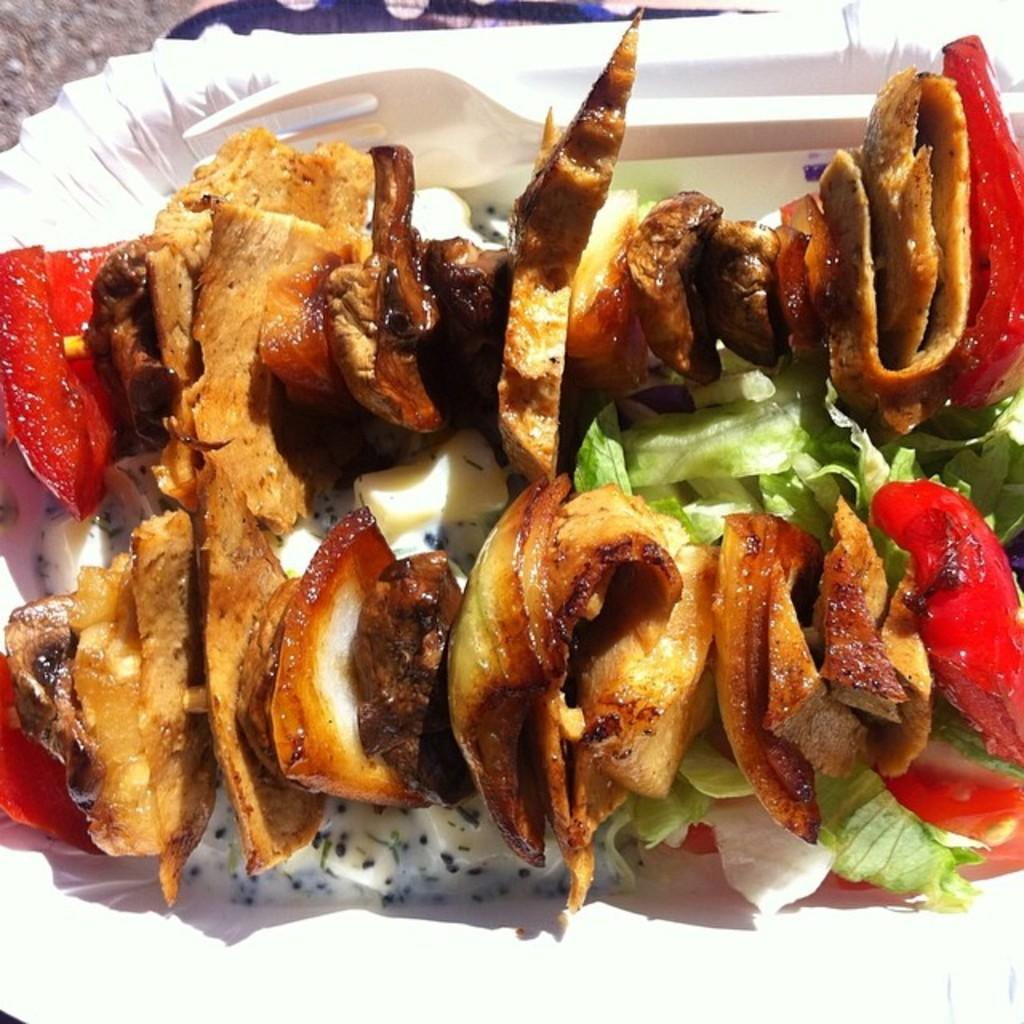What color is the plate in the image? The plate in the image is white. What is on the plate? There are food items on the plate. What utensil is visible in the image? There is a fork visible in the image. Can you see a potato on the plate in the image? There is no potato visible on the plate in the image. Is there a hook attached to the fork in the image? There is no hook present on the fork in the image. 